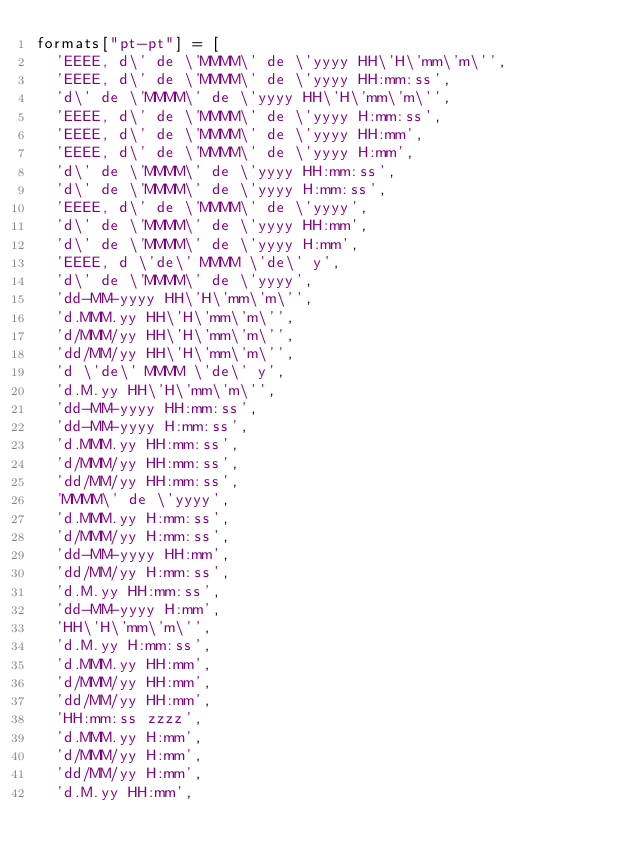Convert code to text. <code><loc_0><loc_0><loc_500><loc_500><_JavaScript_>formats["pt-pt"] = [
  'EEEE, d\' de \'MMMM\' de \'yyyy HH\'H\'mm\'m\'',
  'EEEE, d\' de \'MMMM\' de \'yyyy HH:mm:ss',
  'd\' de \'MMMM\' de \'yyyy HH\'H\'mm\'m\'',
  'EEEE, d\' de \'MMMM\' de \'yyyy H:mm:ss',
  'EEEE, d\' de \'MMMM\' de \'yyyy HH:mm',
  'EEEE, d\' de \'MMMM\' de \'yyyy H:mm',
  'd\' de \'MMMM\' de \'yyyy HH:mm:ss',
  'd\' de \'MMMM\' de \'yyyy H:mm:ss',
  'EEEE, d\' de \'MMMM\' de \'yyyy',
  'd\' de \'MMMM\' de \'yyyy HH:mm',
  'd\' de \'MMMM\' de \'yyyy H:mm',
  'EEEE, d \'de\' MMMM \'de\' y',
  'd\' de \'MMMM\' de \'yyyy',
  'dd-MM-yyyy HH\'H\'mm\'m\'',
  'd.MMM.yy HH\'H\'mm\'m\'',
  'd/MMM/yy HH\'H\'mm\'m\'',
  'dd/MM/yy HH\'H\'mm\'m\'',
  'd \'de\' MMMM \'de\' y',
  'd.M.yy HH\'H\'mm\'m\'',
  'dd-MM-yyyy HH:mm:ss',
  'dd-MM-yyyy H:mm:ss',
  'd.MMM.yy HH:mm:ss',
  'd/MMM/yy HH:mm:ss',
  'dd/MM/yy HH:mm:ss',
  'MMMM\' de \'yyyy',
  'd.MMM.yy H:mm:ss',
  'd/MMM/yy H:mm:ss',
  'dd-MM-yyyy HH:mm',
  'dd/MM/yy H:mm:ss',
  'd.M.yy HH:mm:ss',
  'dd-MM-yyyy H:mm',
  'HH\'H\'mm\'m\'',
  'd.M.yy H:mm:ss',
  'd.MMM.yy HH:mm',
  'd/MMM/yy HH:mm',
  'dd/MM/yy HH:mm',
  'HH:mm:ss zzzz',
  'd.MMM.yy H:mm',
  'd/MMM/yy H:mm',
  'dd/MM/yy H:mm',
  'd.M.yy HH:mm',</code> 